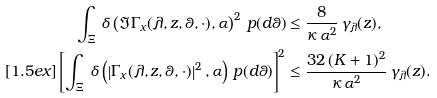<formula> <loc_0><loc_0><loc_500><loc_500>\int _ { \Xi } \, \delta \left ( \Im \Gamma _ { x } ( \lambda , z , \theta , \cdot ) , \alpha \right ) ^ { 2 } \, p ( d \theta ) & \leq \frac { 8 } { \kappa \, \alpha ^ { 2 } } \, \gamma _ { \lambda } ( z ) , \\ [ 1 . 5 e x ] \left [ \int _ { \Xi } \, \delta \left ( \left | \Gamma _ { x } ( \lambda , z , \theta , \cdot ) \right | ^ { 2 } , \alpha \right ) \, p ( d \theta ) \right ] ^ { 2 } & \leq \frac { 3 2 \, ( K + 1 ) ^ { 2 } } { \kappa \, \alpha ^ { 2 } } \, \gamma _ { \lambda } ( z ) .</formula> 